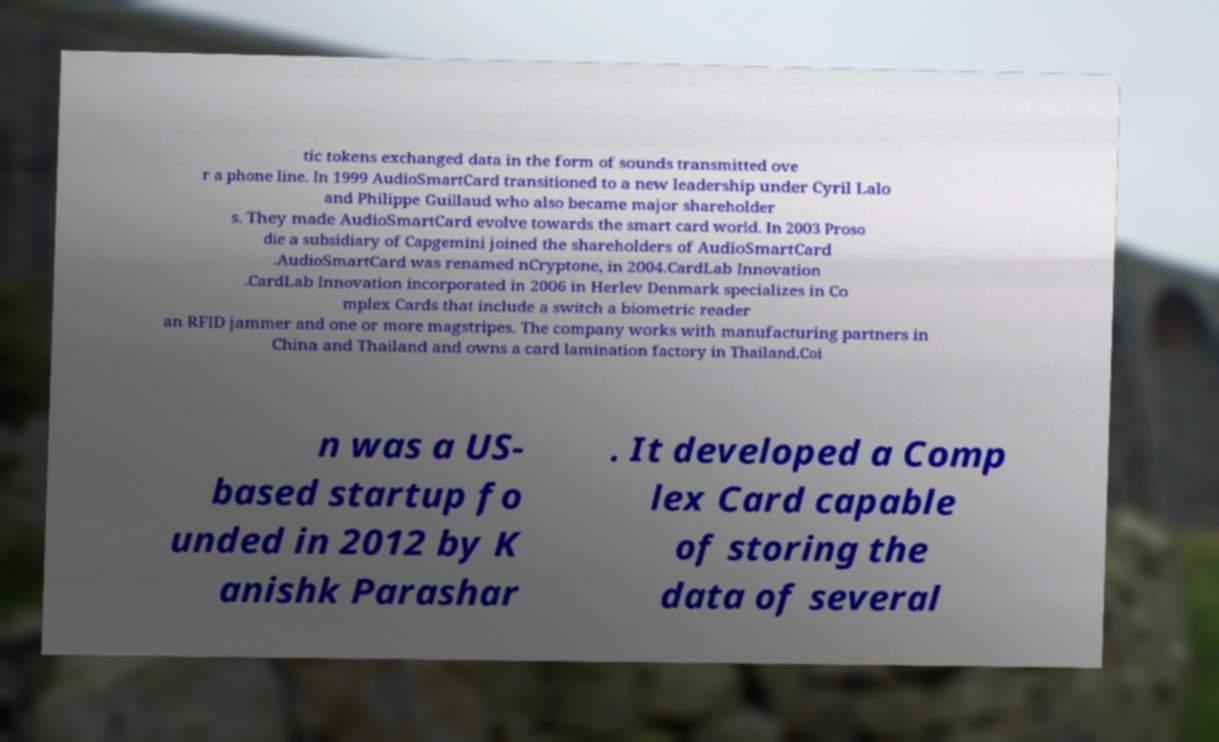Can you accurately transcribe the text from the provided image for me? tic tokens exchanged data in the form of sounds transmitted ove r a phone line. In 1999 AudioSmartCard transitioned to a new leadership under Cyril Lalo and Philippe Guillaud who also became major shareholder s. They made AudioSmartCard evolve towards the smart card world. In 2003 Proso die a subsidiary of Capgemini joined the shareholders of AudioSmartCard .AudioSmartCard was renamed nCryptone, in 2004.CardLab Innovation .CardLab Innovation incorporated in 2006 in Herlev Denmark specializes in Co mplex Cards that include a switch a biometric reader an RFID jammer and one or more magstripes. The company works with manufacturing partners in China and Thailand and owns a card lamination factory in Thailand.Coi n was a US- based startup fo unded in 2012 by K anishk Parashar . It developed a Comp lex Card capable of storing the data of several 